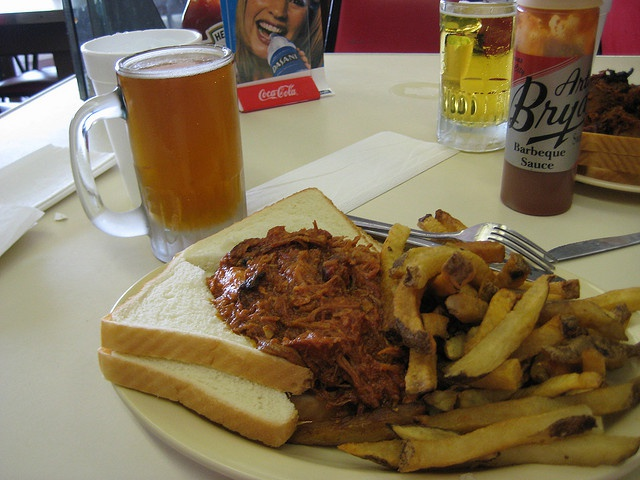Describe the objects in this image and their specific colors. I can see dining table in darkgray, maroon, olive, white, and black tones, cup in white, maroon, darkgray, and lightgray tones, sandwich in white, olive, tan, and lightgray tones, bottle in white, maroon, black, and gray tones, and cup in white, olive, darkgray, and maroon tones in this image. 